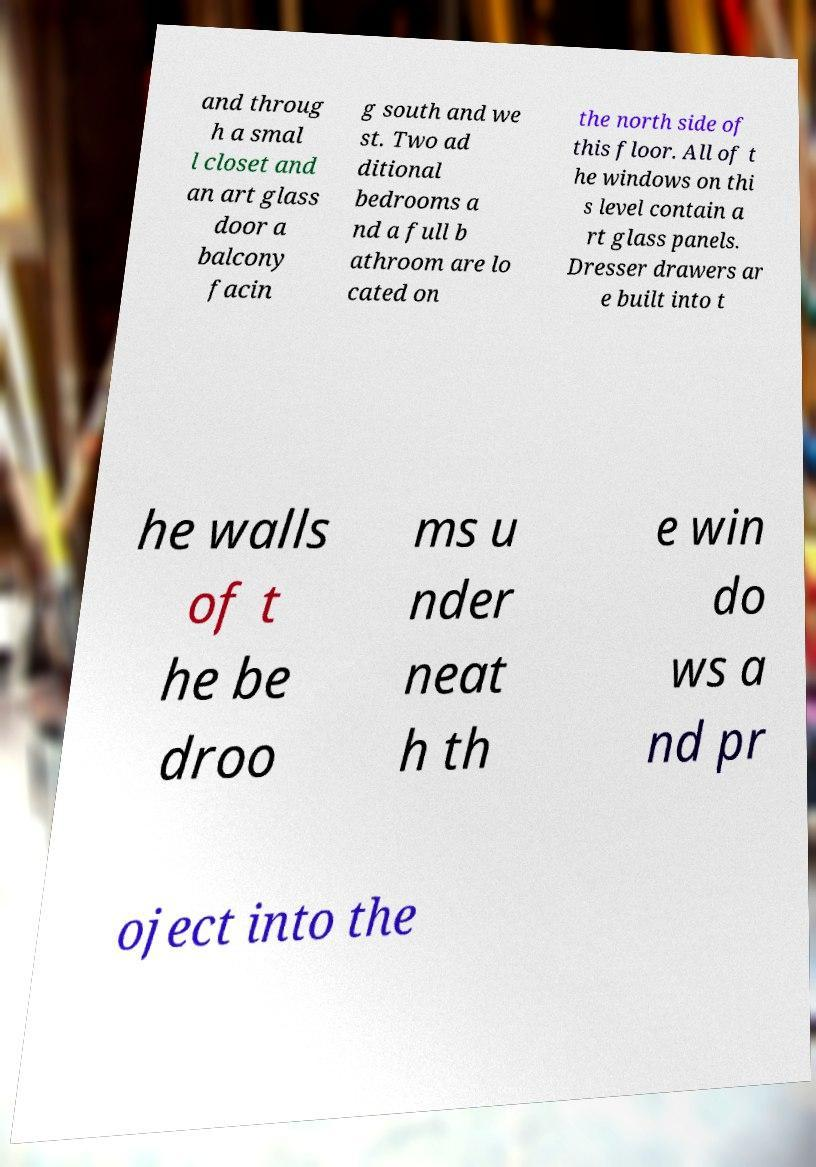Can you accurately transcribe the text from the provided image for me? and throug h a smal l closet and an art glass door a balcony facin g south and we st. Two ad ditional bedrooms a nd a full b athroom are lo cated on the north side of this floor. All of t he windows on thi s level contain a rt glass panels. Dresser drawers ar e built into t he walls of t he be droo ms u nder neat h th e win do ws a nd pr oject into the 